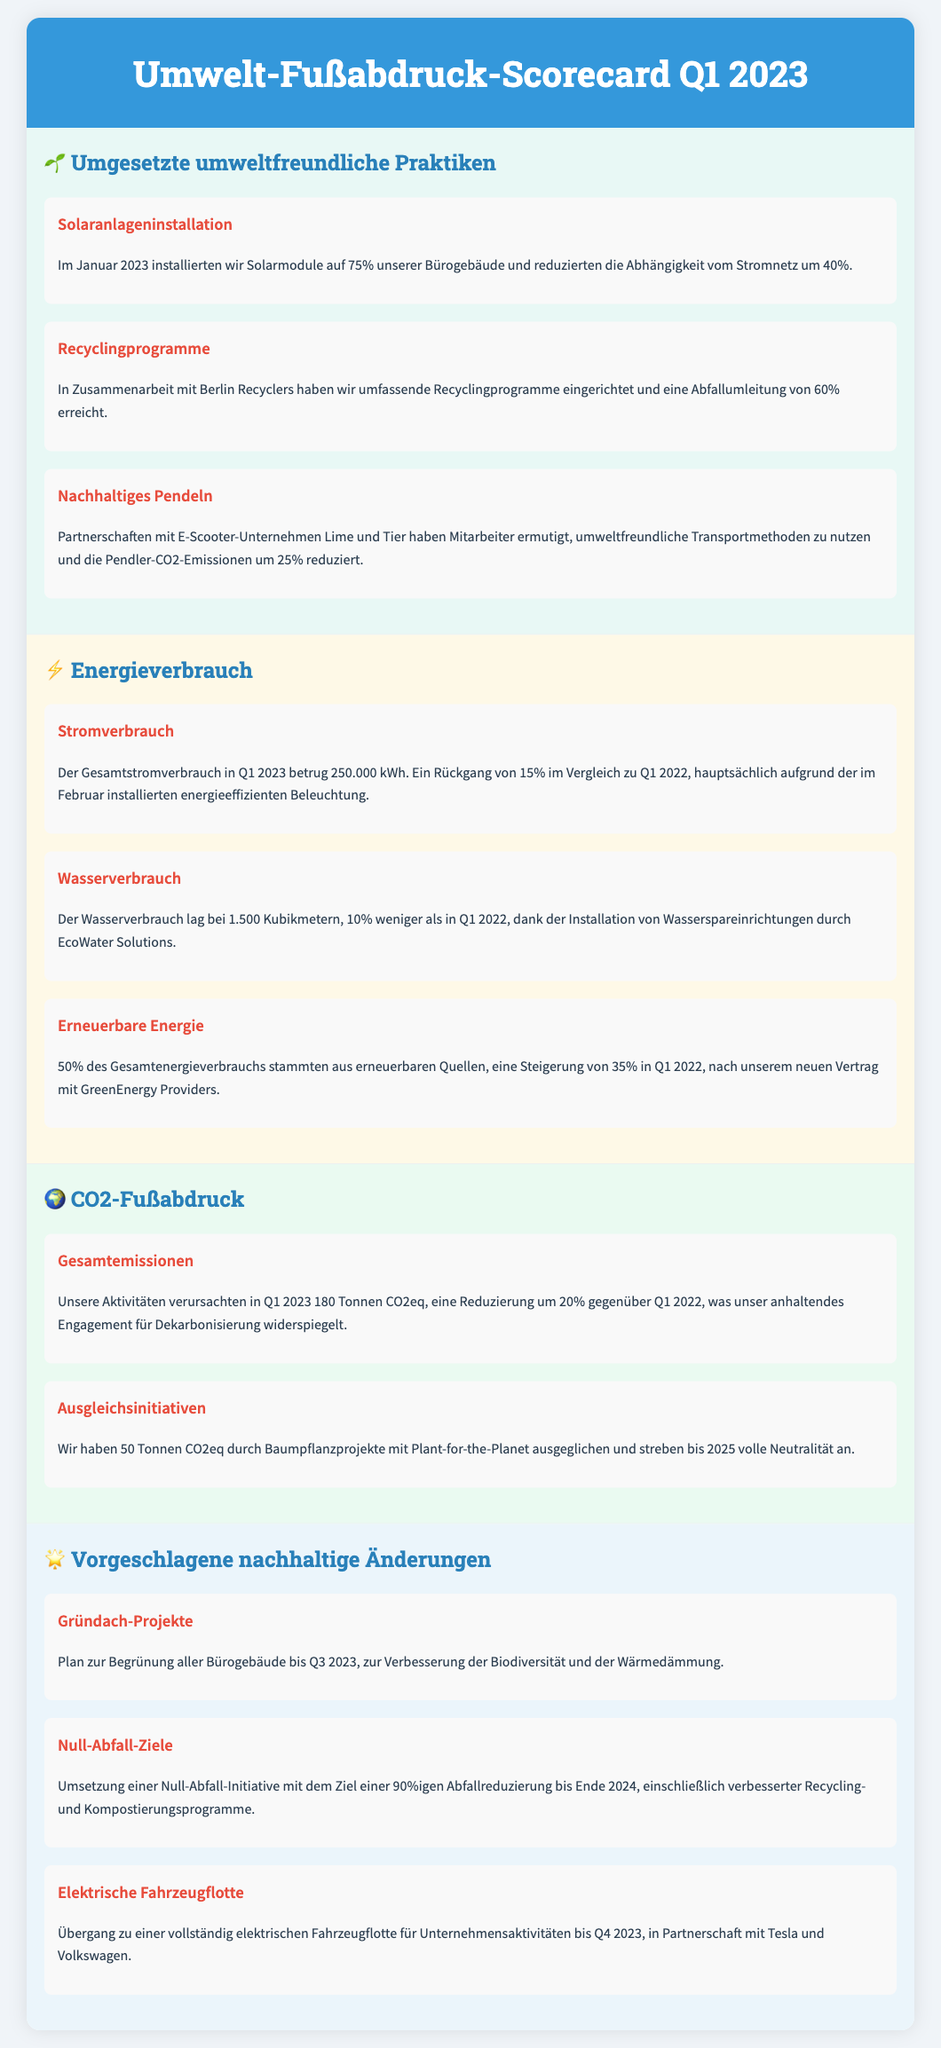Was wurde im Januar 2023 installiert? Im Januar 2023 wurden Solarmodule auf 75% der Bürogebäude installiert.
Answer: Solarmodule Wie hoch war der Gesamtstromverbrauch in Q1 2023? Der Gesamtstromverbrauch in Q1 2023 betrug 250.000 kWh.
Answer: 250.000 kWh Um wie viel Prozent sank der Wasserverbrauch im Vergleich zu Q1 2022? Der Wasserverbrauch sank um 10% im Vergleich zu Q1 2022.
Answer: 10% Wie viel CO2eq wurde durch Baumpflanzprojekte ausgeglichen? Durch Baumpflanzprojekte wurden 50 Tonnen CO2eq ausgeglichen.
Answer: 50 Tonnen Welches Ziel gibt es für die Null-Abfall-Initiative? Das Ziel der Null-Abfall-Initiative ist eine 90%ige Abfallreduzierung bis Ende 2024.
Answer: 90%ige Abfallreduzierung Welche Partnerschaften haben zur Reduktion der Pendler-CO2-Emissionen beigetragen? Partnerschaften mit E-Scooter-Unternehmen Lime und Tier.
Answer: Lime und Tier Was ist der geplante Übergang für die Unternehmensflotte bis Q4 2023? Der geplante Übergang ist zu einer vollständig elektrischen Fahrzeugflotte.
Answer: Elektrische Fahrzeugflotte Wie viel Prozent des Gesamtenergieverbrauchs stammten aus erneuerbaren Quellen? 50% des Gesamtenergieverbrauchs stammten aus erneuerbaren Quellen.
Answer: 50% Welches Projekt wird zur Verbesserung der Biodiversität vorgeschlagen? Die Begrünung aller Bürogebäude bis Q3 2023.
Answer: Begrünung aller Bürogebäude 